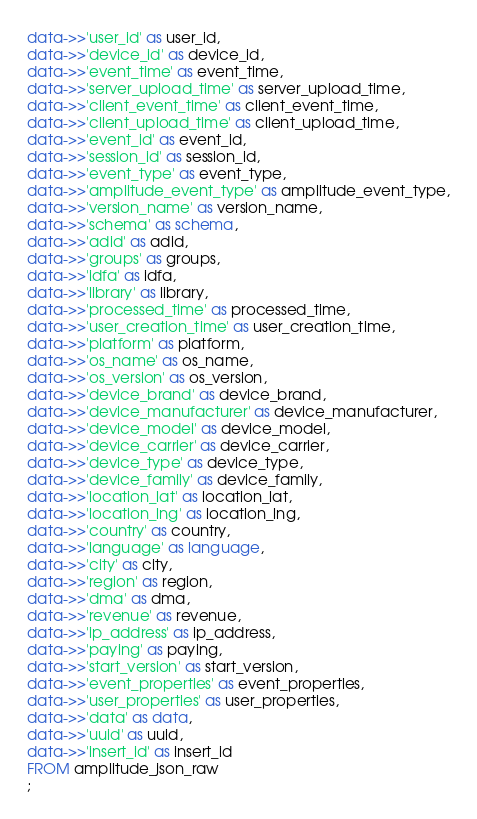<code> <loc_0><loc_0><loc_500><loc_500><_SQL_>data->>'user_id' as user_id,
data->>'device_id' as device_id,
data->>'event_time' as event_time,
data->>'server_upload_time' as server_upload_time,
data->>'client_event_time' as client_event_time,
data->>'client_upload_time' as client_upload_time,
data->>'event_id' as event_id,
data->>'session_id' as session_id,
data->>'event_type' as event_type,
data->>'amplitude_event_type' as amplitude_event_type,
data->>'version_name' as version_name,
data->>'schema' as schema,
data->>'adid' as adid,
data->>'groups' as groups,
data->>'idfa' as idfa,
data->>'library' as library,
data->>'processed_time' as processed_time,
data->>'user_creation_time' as user_creation_time,
data->>'platform' as platform,
data->>'os_name' as os_name,
data->>'os_version' as os_version,
data->>'device_brand' as device_brand,
data->>'device_manufacturer' as device_manufacturer,
data->>'device_model' as device_model,
data->>'device_carrier' as device_carrier,
data->>'device_type' as device_type,
data->>'device_family' as device_family,
data->>'location_lat' as location_lat,
data->>'location_lng' as location_lng,
data->>'country' as country,
data->>'language' as language,
data->>'city' as city,
data->>'region' as region,
data->>'dma' as dma,
data->>'revenue' as revenue,
data->>'ip_address' as ip_address,
data->>'paying' as paying,
data->>'start_version' as start_version,
data->>'event_properties' as event_properties,
data->>'user_properties' as user_properties,
data->>'data' as data,
data->>'uuid' as uuid,
data->>'insert_id' as insert_id
FROM amplitude_json_raw
;
</code> 